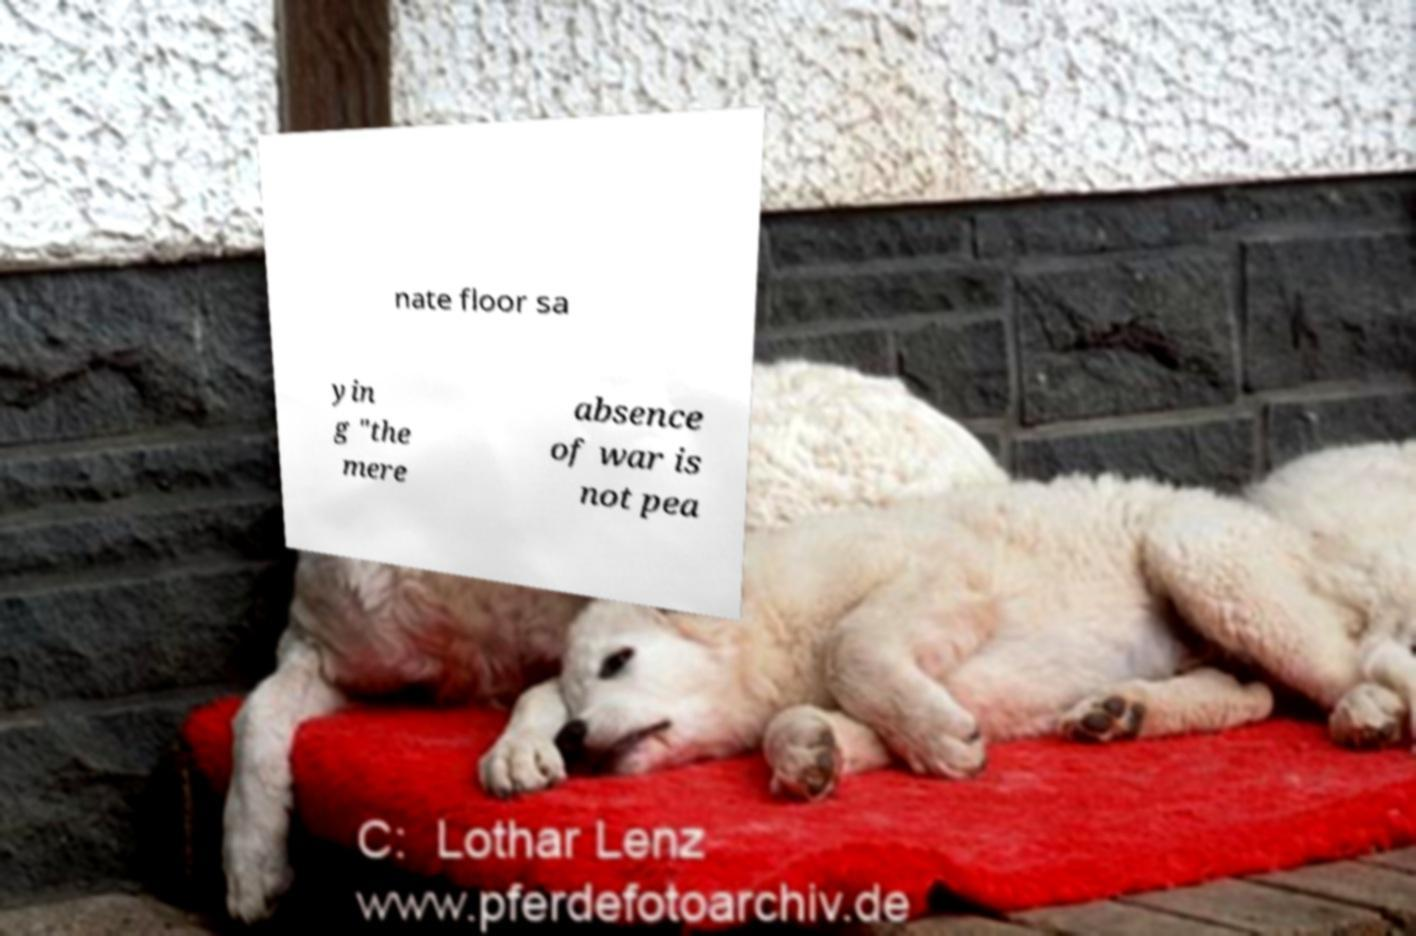Please read and relay the text visible in this image. What does it say? nate floor sa yin g "the mere absence of war is not pea 